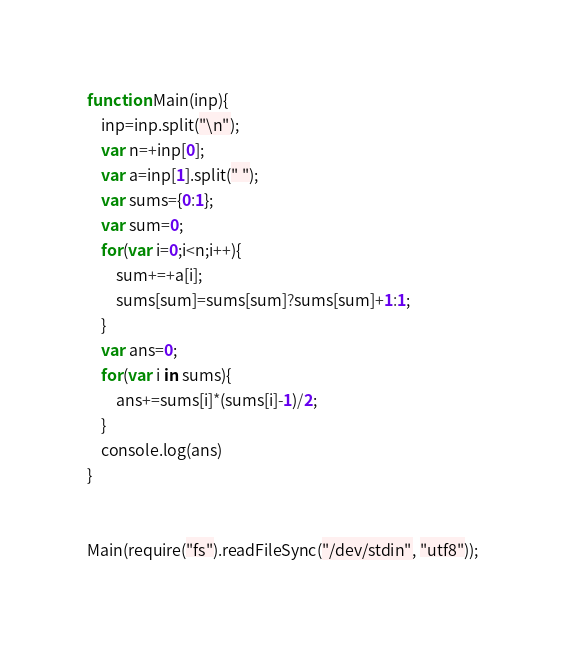Convert code to text. <code><loc_0><loc_0><loc_500><loc_500><_JavaScript_>function Main(inp){
	inp=inp.split("\n");
	var n=+inp[0];
	var a=inp[1].split(" ");
	var sums={0:1};
	var sum=0;
	for(var i=0;i<n;i++){
		sum+=+a[i];
		sums[sum]=sums[sum]?sums[sum]+1:1;
	}
	var ans=0;
	for(var i in sums){
		ans+=sums[i]*(sums[i]-1)/2;
	}
	console.log(ans)
}


Main(require("fs").readFileSync("/dev/stdin", "utf8"));</code> 